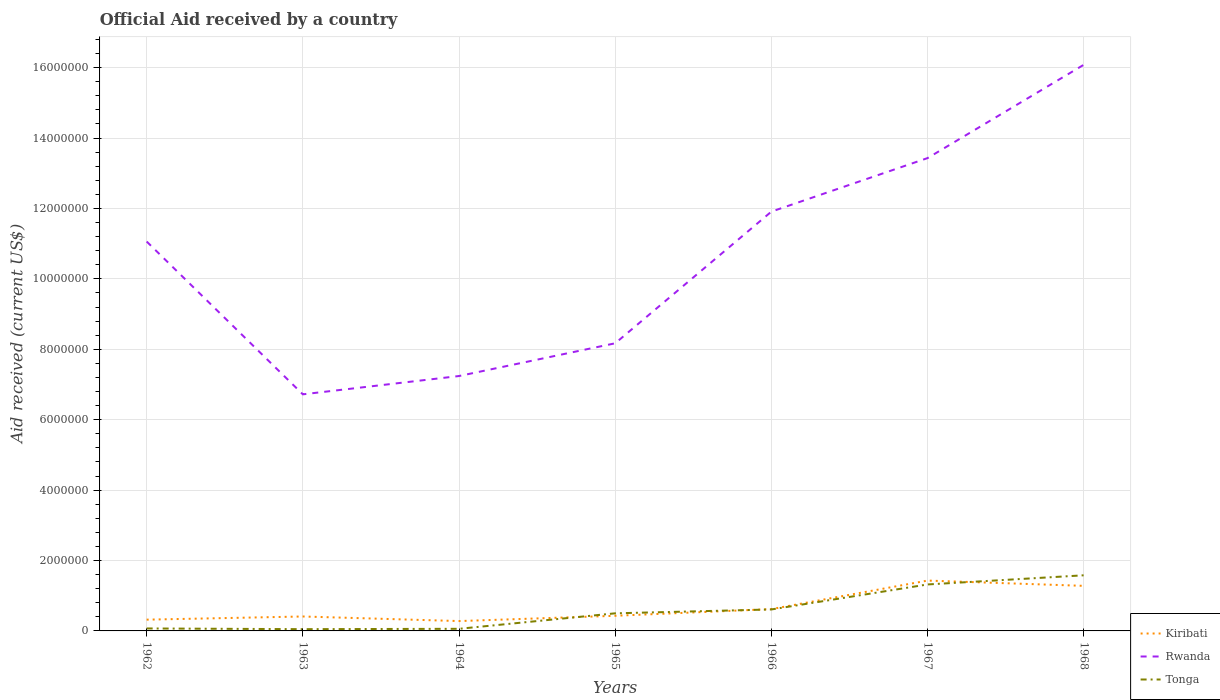Does the line corresponding to Tonga intersect with the line corresponding to Rwanda?
Provide a succinct answer. No. Is the number of lines equal to the number of legend labels?
Make the answer very short. Yes. Across all years, what is the maximum net official aid received in Tonga?
Provide a succinct answer. 5.00e+04. In which year was the net official aid received in Kiribati maximum?
Your response must be concise. 1964. What is the difference between the highest and the second highest net official aid received in Tonga?
Keep it short and to the point. 1.53e+06. How many years are there in the graph?
Ensure brevity in your answer.  7. What is the difference between two consecutive major ticks on the Y-axis?
Your response must be concise. 2.00e+06. How are the legend labels stacked?
Provide a succinct answer. Vertical. What is the title of the graph?
Offer a terse response. Official Aid received by a country. Does "Barbados" appear as one of the legend labels in the graph?
Provide a succinct answer. No. What is the label or title of the X-axis?
Offer a terse response. Years. What is the label or title of the Y-axis?
Make the answer very short. Aid received (current US$). What is the Aid received (current US$) in Kiribati in 1962?
Ensure brevity in your answer.  3.20e+05. What is the Aid received (current US$) of Rwanda in 1962?
Make the answer very short. 1.11e+07. What is the Aid received (current US$) in Rwanda in 1963?
Provide a short and direct response. 6.72e+06. What is the Aid received (current US$) in Kiribati in 1964?
Offer a terse response. 2.80e+05. What is the Aid received (current US$) of Rwanda in 1964?
Offer a terse response. 7.24e+06. What is the Aid received (current US$) in Tonga in 1964?
Provide a succinct answer. 6.00e+04. What is the Aid received (current US$) of Rwanda in 1965?
Make the answer very short. 8.17e+06. What is the Aid received (current US$) of Tonga in 1965?
Your answer should be very brief. 5.00e+05. What is the Aid received (current US$) in Kiribati in 1966?
Offer a terse response. 6.20e+05. What is the Aid received (current US$) in Rwanda in 1966?
Ensure brevity in your answer.  1.19e+07. What is the Aid received (current US$) in Tonga in 1966?
Keep it short and to the point. 6.10e+05. What is the Aid received (current US$) of Kiribati in 1967?
Ensure brevity in your answer.  1.43e+06. What is the Aid received (current US$) of Rwanda in 1967?
Make the answer very short. 1.34e+07. What is the Aid received (current US$) in Tonga in 1967?
Your response must be concise. 1.32e+06. What is the Aid received (current US$) in Kiribati in 1968?
Offer a terse response. 1.28e+06. What is the Aid received (current US$) of Rwanda in 1968?
Offer a very short reply. 1.61e+07. What is the Aid received (current US$) of Tonga in 1968?
Your answer should be compact. 1.58e+06. Across all years, what is the maximum Aid received (current US$) of Kiribati?
Your answer should be compact. 1.43e+06. Across all years, what is the maximum Aid received (current US$) in Rwanda?
Provide a short and direct response. 1.61e+07. Across all years, what is the maximum Aid received (current US$) of Tonga?
Your response must be concise. 1.58e+06. Across all years, what is the minimum Aid received (current US$) of Kiribati?
Offer a terse response. 2.80e+05. Across all years, what is the minimum Aid received (current US$) in Rwanda?
Ensure brevity in your answer.  6.72e+06. What is the total Aid received (current US$) in Kiribati in the graph?
Make the answer very short. 4.77e+06. What is the total Aid received (current US$) in Rwanda in the graph?
Give a very brief answer. 7.46e+07. What is the total Aid received (current US$) of Tonga in the graph?
Provide a short and direct response. 4.19e+06. What is the difference between the Aid received (current US$) in Rwanda in 1962 and that in 1963?
Provide a succinct answer. 4.34e+06. What is the difference between the Aid received (current US$) in Tonga in 1962 and that in 1963?
Ensure brevity in your answer.  2.00e+04. What is the difference between the Aid received (current US$) of Kiribati in 1962 and that in 1964?
Ensure brevity in your answer.  4.00e+04. What is the difference between the Aid received (current US$) in Rwanda in 1962 and that in 1964?
Your response must be concise. 3.82e+06. What is the difference between the Aid received (current US$) in Tonga in 1962 and that in 1964?
Offer a terse response. 10000. What is the difference between the Aid received (current US$) of Kiribati in 1962 and that in 1965?
Make the answer very short. -1.10e+05. What is the difference between the Aid received (current US$) of Rwanda in 1962 and that in 1965?
Give a very brief answer. 2.89e+06. What is the difference between the Aid received (current US$) in Tonga in 1962 and that in 1965?
Provide a succinct answer. -4.30e+05. What is the difference between the Aid received (current US$) of Rwanda in 1962 and that in 1966?
Your answer should be very brief. -8.50e+05. What is the difference between the Aid received (current US$) of Tonga in 1962 and that in 1966?
Offer a terse response. -5.40e+05. What is the difference between the Aid received (current US$) in Kiribati in 1962 and that in 1967?
Make the answer very short. -1.11e+06. What is the difference between the Aid received (current US$) in Rwanda in 1962 and that in 1967?
Give a very brief answer. -2.37e+06. What is the difference between the Aid received (current US$) of Tonga in 1962 and that in 1967?
Your answer should be very brief. -1.25e+06. What is the difference between the Aid received (current US$) of Kiribati in 1962 and that in 1968?
Offer a very short reply. -9.60e+05. What is the difference between the Aid received (current US$) in Rwanda in 1962 and that in 1968?
Make the answer very short. -5.02e+06. What is the difference between the Aid received (current US$) of Tonga in 1962 and that in 1968?
Offer a very short reply. -1.51e+06. What is the difference between the Aid received (current US$) in Rwanda in 1963 and that in 1964?
Offer a terse response. -5.20e+05. What is the difference between the Aid received (current US$) in Tonga in 1963 and that in 1964?
Your answer should be compact. -10000. What is the difference between the Aid received (current US$) of Kiribati in 1963 and that in 1965?
Offer a very short reply. -2.00e+04. What is the difference between the Aid received (current US$) in Rwanda in 1963 and that in 1965?
Keep it short and to the point. -1.45e+06. What is the difference between the Aid received (current US$) of Tonga in 1963 and that in 1965?
Make the answer very short. -4.50e+05. What is the difference between the Aid received (current US$) in Kiribati in 1963 and that in 1966?
Give a very brief answer. -2.10e+05. What is the difference between the Aid received (current US$) of Rwanda in 1963 and that in 1966?
Ensure brevity in your answer.  -5.19e+06. What is the difference between the Aid received (current US$) in Tonga in 1963 and that in 1966?
Your answer should be very brief. -5.60e+05. What is the difference between the Aid received (current US$) in Kiribati in 1963 and that in 1967?
Offer a terse response. -1.02e+06. What is the difference between the Aid received (current US$) of Rwanda in 1963 and that in 1967?
Your answer should be very brief. -6.71e+06. What is the difference between the Aid received (current US$) in Tonga in 1963 and that in 1967?
Keep it short and to the point. -1.27e+06. What is the difference between the Aid received (current US$) of Kiribati in 1963 and that in 1968?
Give a very brief answer. -8.70e+05. What is the difference between the Aid received (current US$) in Rwanda in 1963 and that in 1968?
Give a very brief answer. -9.36e+06. What is the difference between the Aid received (current US$) of Tonga in 1963 and that in 1968?
Provide a succinct answer. -1.53e+06. What is the difference between the Aid received (current US$) of Rwanda in 1964 and that in 1965?
Your answer should be very brief. -9.30e+05. What is the difference between the Aid received (current US$) in Tonga in 1964 and that in 1965?
Make the answer very short. -4.40e+05. What is the difference between the Aid received (current US$) in Kiribati in 1964 and that in 1966?
Offer a very short reply. -3.40e+05. What is the difference between the Aid received (current US$) of Rwanda in 1964 and that in 1966?
Your response must be concise. -4.67e+06. What is the difference between the Aid received (current US$) of Tonga in 1964 and that in 1966?
Your response must be concise. -5.50e+05. What is the difference between the Aid received (current US$) in Kiribati in 1964 and that in 1967?
Make the answer very short. -1.15e+06. What is the difference between the Aid received (current US$) of Rwanda in 1964 and that in 1967?
Provide a succinct answer. -6.19e+06. What is the difference between the Aid received (current US$) in Tonga in 1964 and that in 1967?
Offer a very short reply. -1.26e+06. What is the difference between the Aid received (current US$) in Kiribati in 1964 and that in 1968?
Your answer should be very brief. -1.00e+06. What is the difference between the Aid received (current US$) of Rwanda in 1964 and that in 1968?
Keep it short and to the point. -8.84e+06. What is the difference between the Aid received (current US$) in Tonga in 1964 and that in 1968?
Keep it short and to the point. -1.52e+06. What is the difference between the Aid received (current US$) of Rwanda in 1965 and that in 1966?
Offer a very short reply. -3.74e+06. What is the difference between the Aid received (current US$) of Kiribati in 1965 and that in 1967?
Offer a very short reply. -1.00e+06. What is the difference between the Aid received (current US$) in Rwanda in 1965 and that in 1967?
Your response must be concise. -5.26e+06. What is the difference between the Aid received (current US$) of Tonga in 1965 and that in 1967?
Offer a very short reply. -8.20e+05. What is the difference between the Aid received (current US$) in Kiribati in 1965 and that in 1968?
Provide a short and direct response. -8.50e+05. What is the difference between the Aid received (current US$) in Rwanda in 1965 and that in 1968?
Keep it short and to the point. -7.91e+06. What is the difference between the Aid received (current US$) of Tonga in 1965 and that in 1968?
Offer a terse response. -1.08e+06. What is the difference between the Aid received (current US$) of Kiribati in 1966 and that in 1967?
Keep it short and to the point. -8.10e+05. What is the difference between the Aid received (current US$) in Rwanda in 1966 and that in 1967?
Make the answer very short. -1.52e+06. What is the difference between the Aid received (current US$) of Tonga in 1966 and that in 1967?
Give a very brief answer. -7.10e+05. What is the difference between the Aid received (current US$) in Kiribati in 1966 and that in 1968?
Make the answer very short. -6.60e+05. What is the difference between the Aid received (current US$) of Rwanda in 1966 and that in 1968?
Keep it short and to the point. -4.17e+06. What is the difference between the Aid received (current US$) in Tonga in 1966 and that in 1968?
Your response must be concise. -9.70e+05. What is the difference between the Aid received (current US$) in Kiribati in 1967 and that in 1968?
Ensure brevity in your answer.  1.50e+05. What is the difference between the Aid received (current US$) of Rwanda in 1967 and that in 1968?
Your answer should be very brief. -2.65e+06. What is the difference between the Aid received (current US$) in Tonga in 1967 and that in 1968?
Ensure brevity in your answer.  -2.60e+05. What is the difference between the Aid received (current US$) of Kiribati in 1962 and the Aid received (current US$) of Rwanda in 1963?
Your response must be concise. -6.40e+06. What is the difference between the Aid received (current US$) in Kiribati in 1962 and the Aid received (current US$) in Tonga in 1963?
Offer a terse response. 2.70e+05. What is the difference between the Aid received (current US$) of Rwanda in 1962 and the Aid received (current US$) of Tonga in 1963?
Your answer should be very brief. 1.10e+07. What is the difference between the Aid received (current US$) of Kiribati in 1962 and the Aid received (current US$) of Rwanda in 1964?
Your answer should be very brief. -6.92e+06. What is the difference between the Aid received (current US$) in Rwanda in 1962 and the Aid received (current US$) in Tonga in 1964?
Offer a terse response. 1.10e+07. What is the difference between the Aid received (current US$) of Kiribati in 1962 and the Aid received (current US$) of Rwanda in 1965?
Your response must be concise. -7.85e+06. What is the difference between the Aid received (current US$) of Rwanda in 1962 and the Aid received (current US$) of Tonga in 1965?
Ensure brevity in your answer.  1.06e+07. What is the difference between the Aid received (current US$) in Kiribati in 1962 and the Aid received (current US$) in Rwanda in 1966?
Keep it short and to the point. -1.16e+07. What is the difference between the Aid received (current US$) of Rwanda in 1962 and the Aid received (current US$) of Tonga in 1966?
Your answer should be compact. 1.04e+07. What is the difference between the Aid received (current US$) of Kiribati in 1962 and the Aid received (current US$) of Rwanda in 1967?
Your response must be concise. -1.31e+07. What is the difference between the Aid received (current US$) in Kiribati in 1962 and the Aid received (current US$) in Tonga in 1967?
Ensure brevity in your answer.  -1.00e+06. What is the difference between the Aid received (current US$) in Rwanda in 1962 and the Aid received (current US$) in Tonga in 1967?
Your response must be concise. 9.74e+06. What is the difference between the Aid received (current US$) of Kiribati in 1962 and the Aid received (current US$) of Rwanda in 1968?
Keep it short and to the point. -1.58e+07. What is the difference between the Aid received (current US$) of Kiribati in 1962 and the Aid received (current US$) of Tonga in 1968?
Your answer should be compact. -1.26e+06. What is the difference between the Aid received (current US$) of Rwanda in 1962 and the Aid received (current US$) of Tonga in 1968?
Offer a terse response. 9.48e+06. What is the difference between the Aid received (current US$) in Kiribati in 1963 and the Aid received (current US$) in Rwanda in 1964?
Your answer should be compact. -6.83e+06. What is the difference between the Aid received (current US$) of Rwanda in 1963 and the Aid received (current US$) of Tonga in 1964?
Give a very brief answer. 6.66e+06. What is the difference between the Aid received (current US$) in Kiribati in 1963 and the Aid received (current US$) in Rwanda in 1965?
Your answer should be very brief. -7.76e+06. What is the difference between the Aid received (current US$) in Kiribati in 1963 and the Aid received (current US$) in Tonga in 1965?
Provide a succinct answer. -9.00e+04. What is the difference between the Aid received (current US$) of Rwanda in 1963 and the Aid received (current US$) of Tonga in 1965?
Offer a terse response. 6.22e+06. What is the difference between the Aid received (current US$) in Kiribati in 1963 and the Aid received (current US$) in Rwanda in 1966?
Provide a short and direct response. -1.15e+07. What is the difference between the Aid received (current US$) of Rwanda in 1963 and the Aid received (current US$) of Tonga in 1966?
Ensure brevity in your answer.  6.11e+06. What is the difference between the Aid received (current US$) in Kiribati in 1963 and the Aid received (current US$) in Rwanda in 1967?
Offer a terse response. -1.30e+07. What is the difference between the Aid received (current US$) in Kiribati in 1963 and the Aid received (current US$) in Tonga in 1967?
Your answer should be compact. -9.10e+05. What is the difference between the Aid received (current US$) in Rwanda in 1963 and the Aid received (current US$) in Tonga in 1967?
Keep it short and to the point. 5.40e+06. What is the difference between the Aid received (current US$) of Kiribati in 1963 and the Aid received (current US$) of Rwanda in 1968?
Your answer should be very brief. -1.57e+07. What is the difference between the Aid received (current US$) of Kiribati in 1963 and the Aid received (current US$) of Tonga in 1968?
Keep it short and to the point. -1.17e+06. What is the difference between the Aid received (current US$) in Rwanda in 1963 and the Aid received (current US$) in Tonga in 1968?
Offer a very short reply. 5.14e+06. What is the difference between the Aid received (current US$) in Kiribati in 1964 and the Aid received (current US$) in Rwanda in 1965?
Offer a terse response. -7.89e+06. What is the difference between the Aid received (current US$) in Rwanda in 1964 and the Aid received (current US$) in Tonga in 1965?
Offer a terse response. 6.74e+06. What is the difference between the Aid received (current US$) in Kiribati in 1964 and the Aid received (current US$) in Rwanda in 1966?
Provide a short and direct response. -1.16e+07. What is the difference between the Aid received (current US$) of Kiribati in 1964 and the Aid received (current US$) of Tonga in 1966?
Provide a succinct answer. -3.30e+05. What is the difference between the Aid received (current US$) in Rwanda in 1964 and the Aid received (current US$) in Tonga in 1966?
Offer a very short reply. 6.63e+06. What is the difference between the Aid received (current US$) in Kiribati in 1964 and the Aid received (current US$) in Rwanda in 1967?
Offer a very short reply. -1.32e+07. What is the difference between the Aid received (current US$) of Kiribati in 1964 and the Aid received (current US$) of Tonga in 1967?
Make the answer very short. -1.04e+06. What is the difference between the Aid received (current US$) of Rwanda in 1964 and the Aid received (current US$) of Tonga in 1967?
Provide a short and direct response. 5.92e+06. What is the difference between the Aid received (current US$) in Kiribati in 1964 and the Aid received (current US$) in Rwanda in 1968?
Give a very brief answer. -1.58e+07. What is the difference between the Aid received (current US$) of Kiribati in 1964 and the Aid received (current US$) of Tonga in 1968?
Offer a terse response. -1.30e+06. What is the difference between the Aid received (current US$) in Rwanda in 1964 and the Aid received (current US$) in Tonga in 1968?
Your answer should be compact. 5.66e+06. What is the difference between the Aid received (current US$) in Kiribati in 1965 and the Aid received (current US$) in Rwanda in 1966?
Your response must be concise. -1.15e+07. What is the difference between the Aid received (current US$) in Rwanda in 1965 and the Aid received (current US$) in Tonga in 1966?
Keep it short and to the point. 7.56e+06. What is the difference between the Aid received (current US$) of Kiribati in 1965 and the Aid received (current US$) of Rwanda in 1967?
Your answer should be very brief. -1.30e+07. What is the difference between the Aid received (current US$) in Kiribati in 1965 and the Aid received (current US$) in Tonga in 1967?
Make the answer very short. -8.90e+05. What is the difference between the Aid received (current US$) of Rwanda in 1965 and the Aid received (current US$) of Tonga in 1967?
Provide a succinct answer. 6.85e+06. What is the difference between the Aid received (current US$) in Kiribati in 1965 and the Aid received (current US$) in Rwanda in 1968?
Give a very brief answer. -1.56e+07. What is the difference between the Aid received (current US$) of Kiribati in 1965 and the Aid received (current US$) of Tonga in 1968?
Your response must be concise. -1.15e+06. What is the difference between the Aid received (current US$) of Rwanda in 1965 and the Aid received (current US$) of Tonga in 1968?
Keep it short and to the point. 6.59e+06. What is the difference between the Aid received (current US$) in Kiribati in 1966 and the Aid received (current US$) in Rwanda in 1967?
Offer a very short reply. -1.28e+07. What is the difference between the Aid received (current US$) in Kiribati in 1966 and the Aid received (current US$) in Tonga in 1967?
Your response must be concise. -7.00e+05. What is the difference between the Aid received (current US$) in Rwanda in 1966 and the Aid received (current US$) in Tonga in 1967?
Offer a terse response. 1.06e+07. What is the difference between the Aid received (current US$) in Kiribati in 1966 and the Aid received (current US$) in Rwanda in 1968?
Keep it short and to the point. -1.55e+07. What is the difference between the Aid received (current US$) of Kiribati in 1966 and the Aid received (current US$) of Tonga in 1968?
Keep it short and to the point. -9.60e+05. What is the difference between the Aid received (current US$) in Rwanda in 1966 and the Aid received (current US$) in Tonga in 1968?
Offer a very short reply. 1.03e+07. What is the difference between the Aid received (current US$) of Kiribati in 1967 and the Aid received (current US$) of Rwanda in 1968?
Keep it short and to the point. -1.46e+07. What is the difference between the Aid received (current US$) of Rwanda in 1967 and the Aid received (current US$) of Tonga in 1968?
Provide a short and direct response. 1.18e+07. What is the average Aid received (current US$) in Kiribati per year?
Offer a very short reply. 6.81e+05. What is the average Aid received (current US$) of Rwanda per year?
Provide a short and direct response. 1.07e+07. What is the average Aid received (current US$) in Tonga per year?
Keep it short and to the point. 5.99e+05. In the year 1962, what is the difference between the Aid received (current US$) of Kiribati and Aid received (current US$) of Rwanda?
Keep it short and to the point. -1.07e+07. In the year 1962, what is the difference between the Aid received (current US$) in Rwanda and Aid received (current US$) in Tonga?
Offer a very short reply. 1.10e+07. In the year 1963, what is the difference between the Aid received (current US$) in Kiribati and Aid received (current US$) in Rwanda?
Keep it short and to the point. -6.31e+06. In the year 1963, what is the difference between the Aid received (current US$) in Rwanda and Aid received (current US$) in Tonga?
Your answer should be very brief. 6.67e+06. In the year 1964, what is the difference between the Aid received (current US$) of Kiribati and Aid received (current US$) of Rwanda?
Give a very brief answer. -6.96e+06. In the year 1964, what is the difference between the Aid received (current US$) of Kiribati and Aid received (current US$) of Tonga?
Your answer should be compact. 2.20e+05. In the year 1964, what is the difference between the Aid received (current US$) of Rwanda and Aid received (current US$) of Tonga?
Your answer should be very brief. 7.18e+06. In the year 1965, what is the difference between the Aid received (current US$) in Kiribati and Aid received (current US$) in Rwanda?
Offer a very short reply. -7.74e+06. In the year 1965, what is the difference between the Aid received (current US$) in Kiribati and Aid received (current US$) in Tonga?
Offer a terse response. -7.00e+04. In the year 1965, what is the difference between the Aid received (current US$) in Rwanda and Aid received (current US$) in Tonga?
Make the answer very short. 7.67e+06. In the year 1966, what is the difference between the Aid received (current US$) in Kiribati and Aid received (current US$) in Rwanda?
Provide a succinct answer. -1.13e+07. In the year 1966, what is the difference between the Aid received (current US$) of Rwanda and Aid received (current US$) of Tonga?
Provide a short and direct response. 1.13e+07. In the year 1967, what is the difference between the Aid received (current US$) of Kiribati and Aid received (current US$) of Rwanda?
Your answer should be very brief. -1.20e+07. In the year 1967, what is the difference between the Aid received (current US$) of Kiribati and Aid received (current US$) of Tonga?
Ensure brevity in your answer.  1.10e+05. In the year 1967, what is the difference between the Aid received (current US$) of Rwanda and Aid received (current US$) of Tonga?
Your response must be concise. 1.21e+07. In the year 1968, what is the difference between the Aid received (current US$) in Kiribati and Aid received (current US$) in Rwanda?
Offer a very short reply. -1.48e+07. In the year 1968, what is the difference between the Aid received (current US$) in Kiribati and Aid received (current US$) in Tonga?
Provide a succinct answer. -3.00e+05. In the year 1968, what is the difference between the Aid received (current US$) of Rwanda and Aid received (current US$) of Tonga?
Offer a very short reply. 1.45e+07. What is the ratio of the Aid received (current US$) in Kiribati in 1962 to that in 1963?
Ensure brevity in your answer.  0.78. What is the ratio of the Aid received (current US$) in Rwanda in 1962 to that in 1963?
Your answer should be very brief. 1.65. What is the ratio of the Aid received (current US$) of Tonga in 1962 to that in 1963?
Keep it short and to the point. 1.4. What is the ratio of the Aid received (current US$) of Kiribati in 1962 to that in 1964?
Offer a terse response. 1.14. What is the ratio of the Aid received (current US$) of Rwanda in 1962 to that in 1964?
Give a very brief answer. 1.53. What is the ratio of the Aid received (current US$) in Kiribati in 1962 to that in 1965?
Offer a very short reply. 0.74. What is the ratio of the Aid received (current US$) in Rwanda in 1962 to that in 1965?
Offer a terse response. 1.35. What is the ratio of the Aid received (current US$) of Tonga in 1962 to that in 1965?
Give a very brief answer. 0.14. What is the ratio of the Aid received (current US$) of Kiribati in 1962 to that in 1966?
Offer a terse response. 0.52. What is the ratio of the Aid received (current US$) of Rwanda in 1962 to that in 1966?
Provide a succinct answer. 0.93. What is the ratio of the Aid received (current US$) in Tonga in 1962 to that in 1966?
Keep it short and to the point. 0.11. What is the ratio of the Aid received (current US$) in Kiribati in 1962 to that in 1967?
Ensure brevity in your answer.  0.22. What is the ratio of the Aid received (current US$) in Rwanda in 1962 to that in 1967?
Provide a succinct answer. 0.82. What is the ratio of the Aid received (current US$) of Tonga in 1962 to that in 1967?
Make the answer very short. 0.05. What is the ratio of the Aid received (current US$) in Rwanda in 1962 to that in 1968?
Offer a very short reply. 0.69. What is the ratio of the Aid received (current US$) in Tonga in 1962 to that in 1968?
Provide a short and direct response. 0.04. What is the ratio of the Aid received (current US$) in Kiribati in 1963 to that in 1964?
Offer a terse response. 1.46. What is the ratio of the Aid received (current US$) of Rwanda in 1963 to that in 1964?
Make the answer very short. 0.93. What is the ratio of the Aid received (current US$) of Tonga in 1963 to that in 1964?
Your answer should be compact. 0.83. What is the ratio of the Aid received (current US$) of Kiribati in 1963 to that in 1965?
Your answer should be compact. 0.95. What is the ratio of the Aid received (current US$) in Rwanda in 1963 to that in 1965?
Your answer should be very brief. 0.82. What is the ratio of the Aid received (current US$) in Kiribati in 1963 to that in 1966?
Make the answer very short. 0.66. What is the ratio of the Aid received (current US$) in Rwanda in 1963 to that in 1966?
Keep it short and to the point. 0.56. What is the ratio of the Aid received (current US$) in Tonga in 1963 to that in 1966?
Keep it short and to the point. 0.08. What is the ratio of the Aid received (current US$) of Kiribati in 1963 to that in 1967?
Your response must be concise. 0.29. What is the ratio of the Aid received (current US$) of Rwanda in 1963 to that in 1967?
Make the answer very short. 0.5. What is the ratio of the Aid received (current US$) of Tonga in 1963 to that in 1967?
Provide a short and direct response. 0.04. What is the ratio of the Aid received (current US$) of Kiribati in 1963 to that in 1968?
Your answer should be very brief. 0.32. What is the ratio of the Aid received (current US$) in Rwanda in 1963 to that in 1968?
Ensure brevity in your answer.  0.42. What is the ratio of the Aid received (current US$) of Tonga in 1963 to that in 1968?
Offer a terse response. 0.03. What is the ratio of the Aid received (current US$) of Kiribati in 1964 to that in 1965?
Offer a terse response. 0.65. What is the ratio of the Aid received (current US$) in Rwanda in 1964 to that in 1965?
Your answer should be compact. 0.89. What is the ratio of the Aid received (current US$) of Tonga in 1964 to that in 1965?
Ensure brevity in your answer.  0.12. What is the ratio of the Aid received (current US$) in Kiribati in 1964 to that in 1966?
Make the answer very short. 0.45. What is the ratio of the Aid received (current US$) of Rwanda in 1964 to that in 1966?
Offer a terse response. 0.61. What is the ratio of the Aid received (current US$) in Tonga in 1964 to that in 1966?
Your response must be concise. 0.1. What is the ratio of the Aid received (current US$) in Kiribati in 1964 to that in 1967?
Your answer should be compact. 0.2. What is the ratio of the Aid received (current US$) in Rwanda in 1964 to that in 1967?
Provide a succinct answer. 0.54. What is the ratio of the Aid received (current US$) of Tonga in 1964 to that in 1967?
Offer a very short reply. 0.05. What is the ratio of the Aid received (current US$) in Kiribati in 1964 to that in 1968?
Your answer should be very brief. 0.22. What is the ratio of the Aid received (current US$) of Rwanda in 1964 to that in 1968?
Your response must be concise. 0.45. What is the ratio of the Aid received (current US$) in Tonga in 1964 to that in 1968?
Make the answer very short. 0.04. What is the ratio of the Aid received (current US$) in Kiribati in 1965 to that in 1966?
Your answer should be very brief. 0.69. What is the ratio of the Aid received (current US$) in Rwanda in 1965 to that in 1966?
Provide a short and direct response. 0.69. What is the ratio of the Aid received (current US$) in Tonga in 1965 to that in 1966?
Ensure brevity in your answer.  0.82. What is the ratio of the Aid received (current US$) of Kiribati in 1965 to that in 1967?
Make the answer very short. 0.3. What is the ratio of the Aid received (current US$) in Rwanda in 1965 to that in 1967?
Your answer should be very brief. 0.61. What is the ratio of the Aid received (current US$) of Tonga in 1965 to that in 1967?
Give a very brief answer. 0.38. What is the ratio of the Aid received (current US$) in Kiribati in 1965 to that in 1968?
Provide a short and direct response. 0.34. What is the ratio of the Aid received (current US$) of Rwanda in 1965 to that in 1968?
Ensure brevity in your answer.  0.51. What is the ratio of the Aid received (current US$) in Tonga in 1965 to that in 1968?
Provide a short and direct response. 0.32. What is the ratio of the Aid received (current US$) in Kiribati in 1966 to that in 1967?
Offer a very short reply. 0.43. What is the ratio of the Aid received (current US$) of Rwanda in 1966 to that in 1967?
Offer a very short reply. 0.89. What is the ratio of the Aid received (current US$) in Tonga in 1966 to that in 1967?
Provide a succinct answer. 0.46. What is the ratio of the Aid received (current US$) in Kiribati in 1966 to that in 1968?
Make the answer very short. 0.48. What is the ratio of the Aid received (current US$) of Rwanda in 1966 to that in 1968?
Your answer should be very brief. 0.74. What is the ratio of the Aid received (current US$) in Tonga in 1966 to that in 1968?
Keep it short and to the point. 0.39. What is the ratio of the Aid received (current US$) in Kiribati in 1967 to that in 1968?
Ensure brevity in your answer.  1.12. What is the ratio of the Aid received (current US$) in Rwanda in 1967 to that in 1968?
Keep it short and to the point. 0.84. What is the ratio of the Aid received (current US$) in Tonga in 1967 to that in 1968?
Your answer should be compact. 0.84. What is the difference between the highest and the second highest Aid received (current US$) of Kiribati?
Give a very brief answer. 1.50e+05. What is the difference between the highest and the second highest Aid received (current US$) of Rwanda?
Provide a short and direct response. 2.65e+06. What is the difference between the highest and the second highest Aid received (current US$) in Tonga?
Provide a succinct answer. 2.60e+05. What is the difference between the highest and the lowest Aid received (current US$) of Kiribati?
Keep it short and to the point. 1.15e+06. What is the difference between the highest and the lowest Aid received (current US$) in Rwanda?
Offer a very short reply. 9.36e+06. What is the difference between the highest and the lowest Aid received (current US$) in Tonga?
Give a very brief answer. 1.53e+06. 